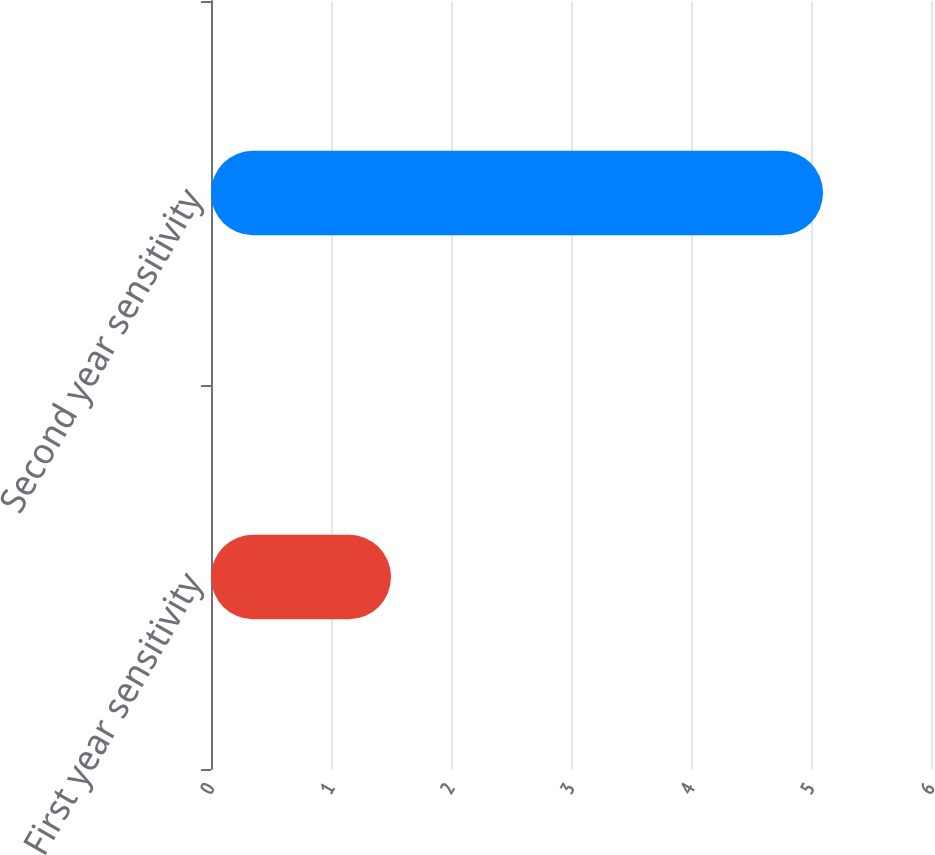<chart> <loc_0><loc_0><loc_500><loc_500><bar_chart><fcel>First year sensitivity<fcel>Second year sensitivity<nl><fcel>1.5<fcel>5.1<nl></chart> 